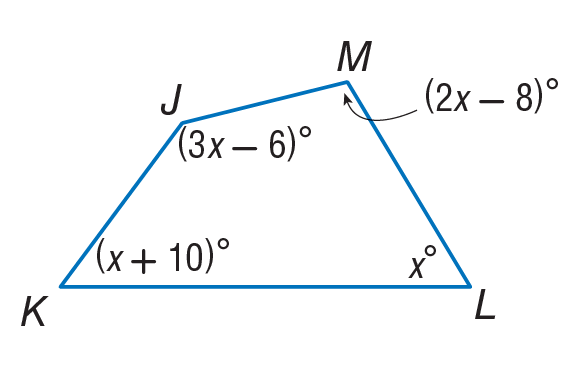Answer the mathemtical geometry problem and directly provide the correct option letter.
Question: Find m \angle K.
Choices: A: 62 B: 72 C: 116 D: 160 A 